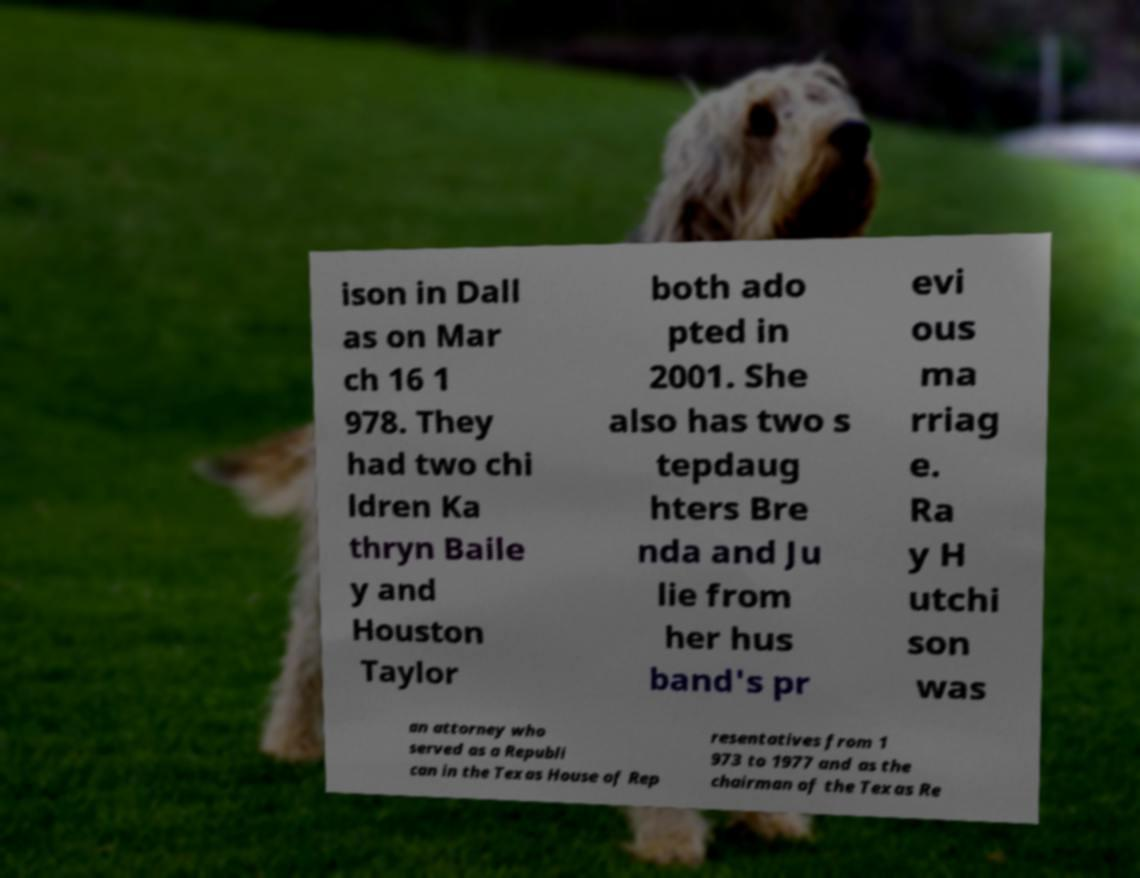Can you read and provide the text displayed in the image?This photo seems to have some interesting text. Can you extract and type it out for me? ison in Dall as on Mar ch 16 1 978. They had two chi ldren Ka thryn Baile y and Houston Taylor both ado pted in 2001. She also has two s tepdaug hters Bre nda and Ju lie from her hus band's pr evi ous ma rriag e. Ra y H utchi son was an attorney who served as a Republi can in the Texas House of Rep resentatives from 1 973 to 1977 and as the chairman of the Texas Re 